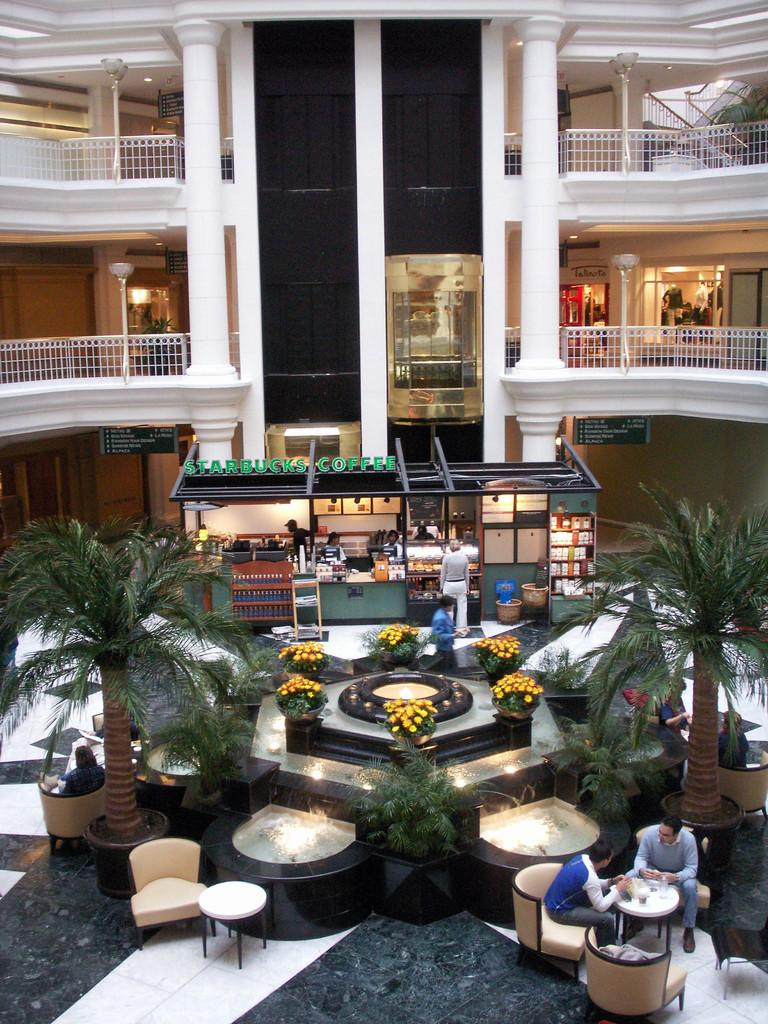<image>
Give a short and clear explanation of the subsequent image. the inside of a mall with a small shop in front labeled as 'starbucks coffee' 